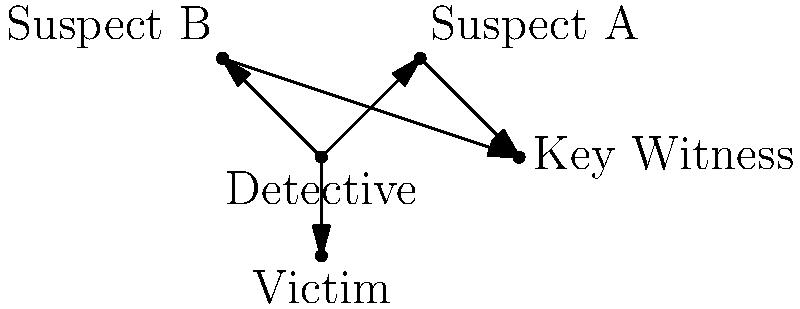In the network diagram representing character relationships in a mystery novel, which character has the highest degree centrality (i.e., the most direct connections to other characters)? To determine the character with the highest degree centrality, we need to count the number of direct connections (edges) for each character in the network diagram:

1. Detective: 3 connections (to Suspect A, Suspect B, and Victim)
2. Suspect A: 2 connections (to Detective and Key Witness)
3. Suspect B: 2 connections (to Detective and Key Witness)
4. Victim: 1 connection (to Detective)
5. Key Witness: 2 connections (to Suspect A and Suspect B)

The character with the most direct connections is the Detective, with 3 connections. This indicates that the Detective has the highest degree centrality in the network, suggesting they play a central role in the mystery novel's plot by interacting directly with the most characters.
Answer: Detective 